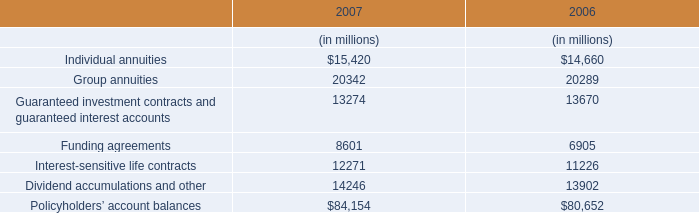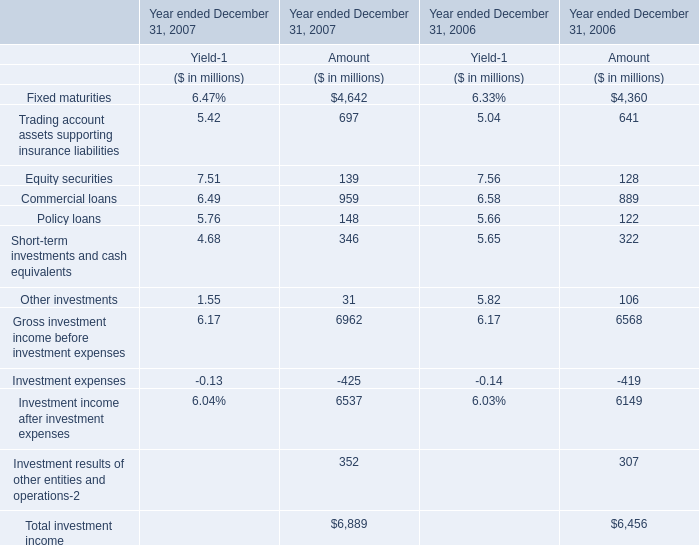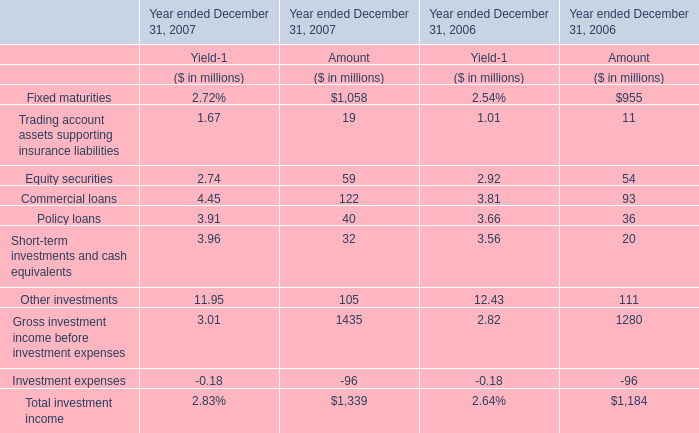In the year with lowest amount of Policy loans, what's the increasing rate of Other investments? 
Computations: ((31 - 106) / 106)
Answer: -0.70755. 